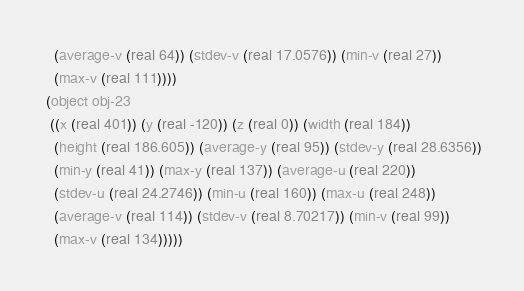Convert code to text. <code><loc_0><loc_0><loc_500><loc_500><_Lisp_>   (average-v (real 64)) (stdev-v (real 17.0576)) (min-v (real 27))
   (max-v (real 111))))
 (object obj-23
  ((x (real 401)) (y (real -120)) (z (real 0)) (width (real 184))
   (height (real 186.605)) (average-y (real 95)) (stdev-y (real 28.6356))
   (min-y (real 41)) (max-y (real 137)) (average-u (real 220))
   (stdev-u (real 24.2746)) (min-u (real 160)) (max-u (real 248))
   (average-v (real 114)) (stdev-v (real 8.70217)) (min-v (real 99))
   (max-v (real 134)))))</code> 